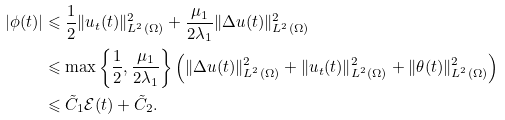Convert formula to latex. <formula><loc_0><loc_0><loc_500><loc_500>| \phi ( t ) | & \leqslant \frac { 1 } { 2 } \| u _ { t } ( t ) \| _ { L ^ { 2 } ( \Omega ) } ^ { 2 } + \frac { \mu _ { 1 } } { 2 \lambda _ { 1 } } \| \Delta u ( t ) \| _ { L ^ { 2 } ( \Omega ) } ^ { 2 } \\ & \leqslant \max \left \{ \frac { 1 } { 2 } , \frac { \mu _ { 1 } } { 2 \lambda _ { 1 } } \right \} \left ( \| \Delta u ( t ) \| _ { L ^ { 2 } ( \Omega ) } ^ { 2 } + \| u _ { t } ( t ) \| _ { L ^ { 2 } ( \Omega ) } ^ { 2 } + \| \theta ( t ) \| ^ { 2 } _ { L ^ { 2 } ( \Omega ) } \right ) \\ & \leqslant \tilde { C } _ { 1 } \mathcal { E } ( t ) + \tilde { C } _ { 2 } .</formula> 